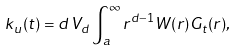Convert formula to latex. <formula><loc_0><loc_0><loc_500><loc_500>k _ { u } ( t ) = d \, V _ { d } \int ^ { \infty } _ { a } r ^ { d - 1 } W ( r ) G _ { t } ( r ) ,</formula> 